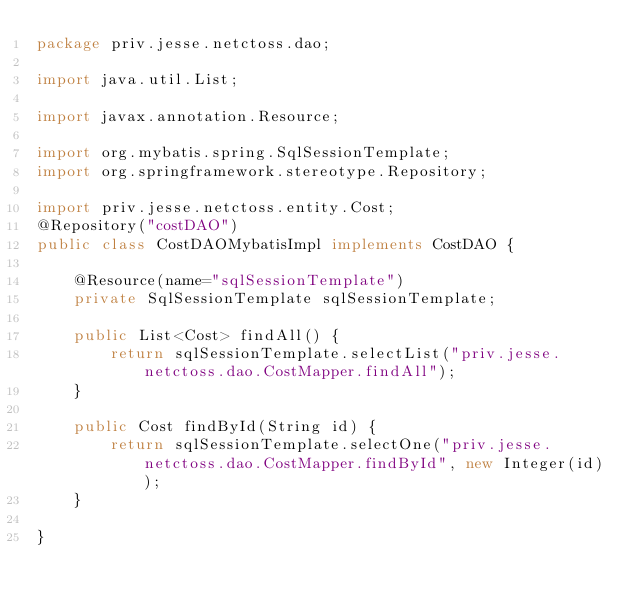Convert code to text. <code><loc_0><loc_0><loc_500><loc_500><_Java_>package priv.jesse.netctoss.dao;

import java.util.List;

import javax.annotation.Resource;

import org.mybatis.spring.SqlSessionTemplate;
import org.springframework.stereotype.Repository;

import priv.jesse.netctoss.entity.Cost;
@Repository("costDAO")
public class CostDAOMybatisImpl implements CostDAO {
	
	@Resource(name="sqlSessionTemplate")
	private SqlSessionTemplate sqlSessionTemplate;
	
	public List<Cost> findAll() {
		return sqlSessionTemplate.selectList("priv.jesse.netctoss.dao.CostMapper.findAll");
	}

	public Cost findById(String id) {
		return sqlSessionTemplate.selectOne("priv.jesse.netctoss.dao.CostMapper.findById", new Integer(id));
	}

}
</code> 